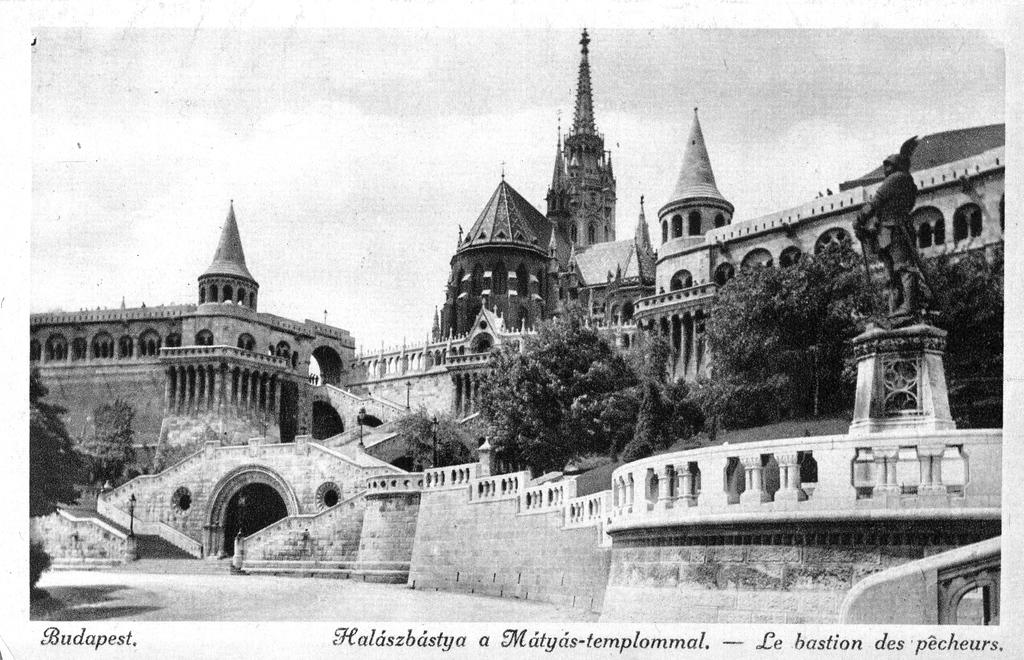What type of buildings can be seen in the image? There are castles in the image. What architectural feature is present in the image? There is an arch in the image. What type of natural elements are visible in the image? There are trees in the image. What type of artwork is present in the image? There is a sculpture in the image. What information is provided at the bottom of the image? There is text written at the bottom of the image. How does the harmony between the castles and trees contribute to the balance of the image? The image does not explicitly convey harmony or balance between the castles and trees; these concepts are not present in the image. 